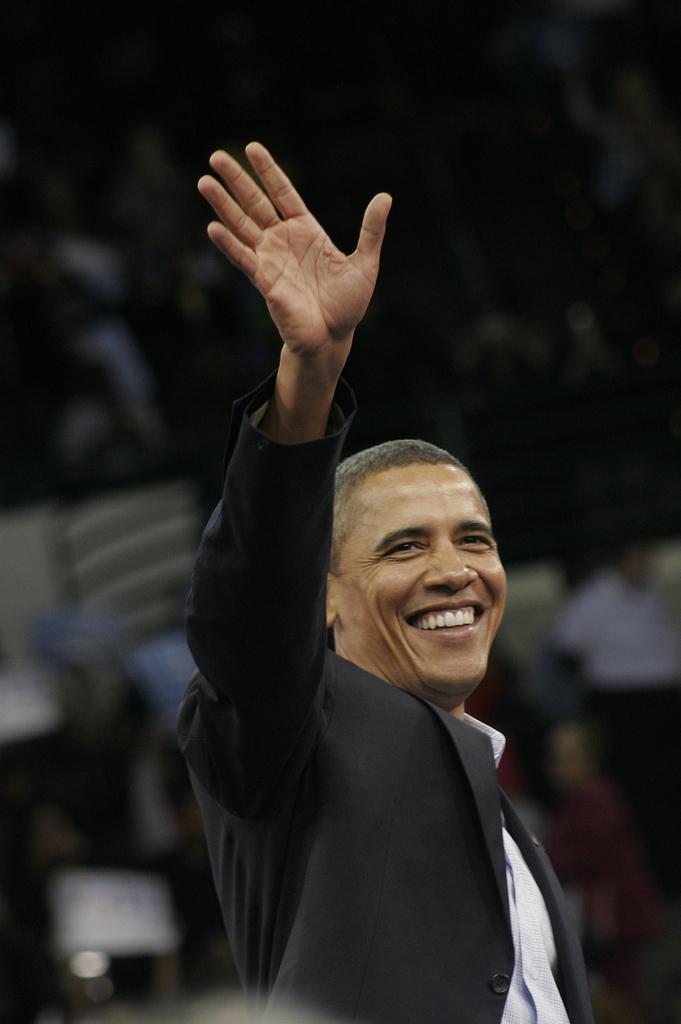Could you give a brief overview of what you see in this image? In the center of the image we can see one person standing and he is smiling, which we can see on his face. In the background it is blurred. 